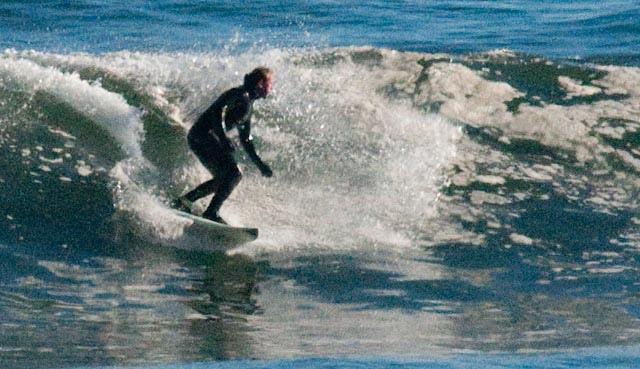What is he doing?
Quick response, please. Surfing. What color is the water?
Answer briefly. Blue. Is the man going towards the waves?
Keep it brief. No. 